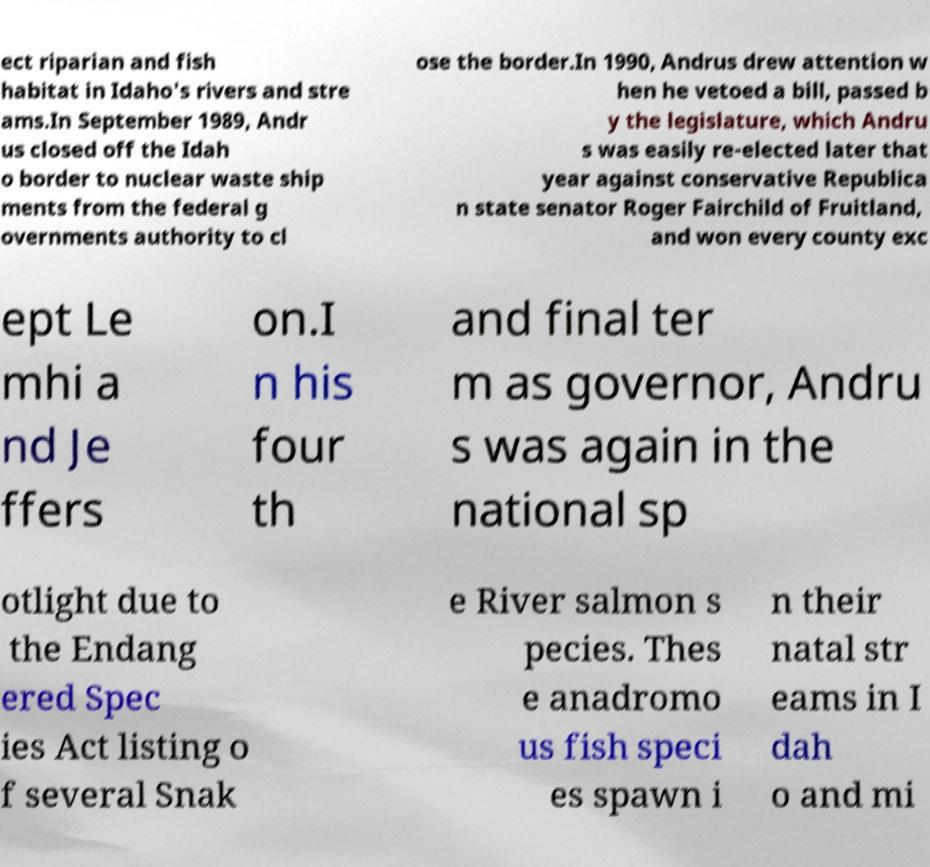Can you read and provide the text displayed in the image?This photo seems to have some interesting text. Can you extract and type it out for me? ect riparian and fish habitat in Idaho's rivers and stre ams.In September 1989, Andr us closed off the Idah o border to nuclear waste ship ments from the federal g overnments authority to cl ose the border.In 1990, Andrus drew attention w hen he vetoed a bill, passed b y the legislature, which Andru s was easily re-elected later that year against conservative Republica n state senator Roger Fairchild of Fruitland, and won every county exc ept Le mhi a nd Je ffers on.I n his four th and final ter m as governor, Andru s was again in the national sp otlight due to the Endang ered Spec ies Act listing o f several Snak e River salmon s pecies. Thes e anadromo us fish speci es spawn i n their natal str eams in I dah o and mi 